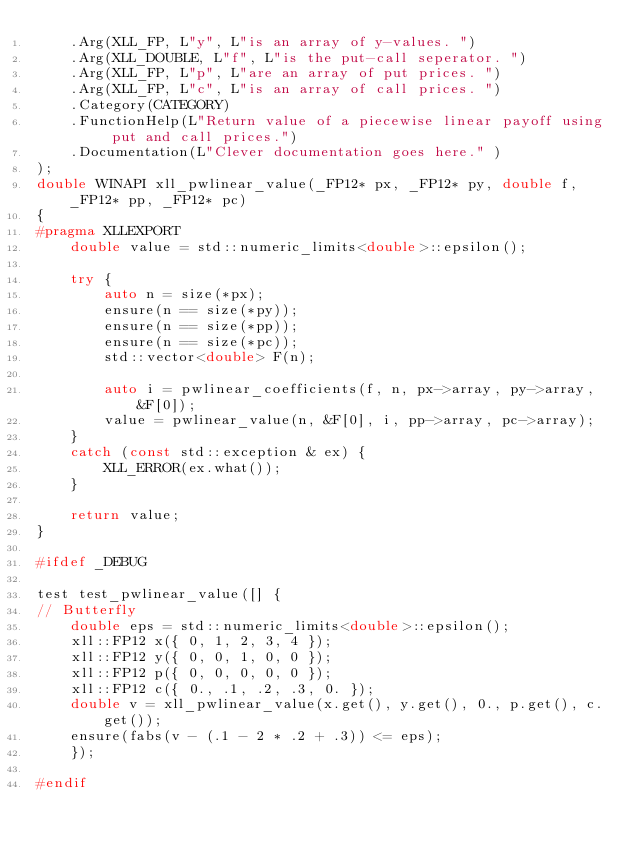Convert code to text. <code><loc_0><loc_0><loc_500><loc_500><_C++_>    .Arg(XLL_FP, L"y", L"is an array of y-values. ")
    .Arg(XLL_DOUBLE, L"f", L"is the put-call seperator. ")
    .Arg(XLL_FP, L"p", L"are an array of put prices. ")
    .Arg(XLL_FP, L"c", L"is an array of call prices. ")
    .Category(CATEGORY)
    .FunctionHelp(L"Return value of a piecewise linear payoff using put and call prices.")
    .Documentation(L"Clever documentation goes here." )
);
double WINAPI xll_pwlinear_value(_FP12* px, _FP12* py, double f, _FP12* pp, _FP12* pc)
{
#pragma XLLEXPORT
    double value = std::numeric_limits<double>::epsilon();

    try {
        auto n = size(*px);
        ensure(n == size(*py));
        ensure(n == size(*pp));
        ensure(n == size(*pc));
        std::vector<double> F(n);
        
        auto i = pwlinear_coefficients(f, n, px->array, py->array, &F[0]);
        value = pwlinear_value(n, &F[0], i, pp->array, pc->array);
    }
    catch (const std::exception & ex) {
        XLL_ERROR(ex.what());
    }

    return value;
}

#ifdef _DEBUG

test test_pwlinear_value([] {
// Butterfly
    double eps = std::numeric_limits<double>::epsilon();
    xll::FP12 x({ 0, 1, 2, 3, 4 });
    xll::FP12 y({ 0, 0, 1, 0, 0 });
    xll::FP12 p({ 0, 0, 0, 0, 0 });
    xll::FP12 c({ 0., .1, .2, .3, 0. });
    double v = xll_pwlinear_value(x.get(), y.get(), 0., p.get(), c.get());
    ensure(fabs(v - (.1 - 2 * .2 + .3)) <= eps);
    });

#endif</code> 